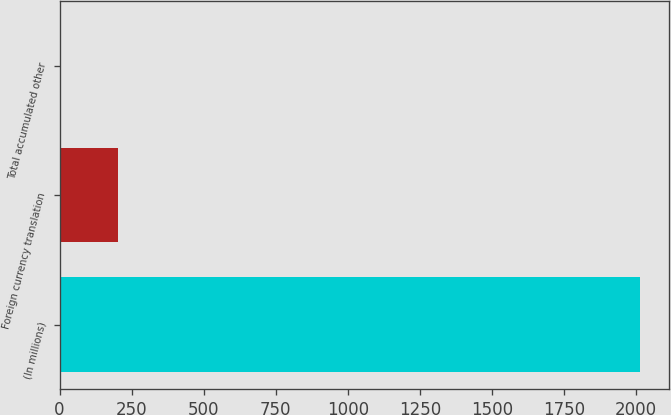Convert chart. <chart><loc_0><loc_0><loc_500><loc_500><bar_chart><fcel>(In millions)<fcel>Foreign currency translation<fcel>Total accumulated other<nl><fcel>2014<fcel>203.2<fcel>2<nl></chart> 